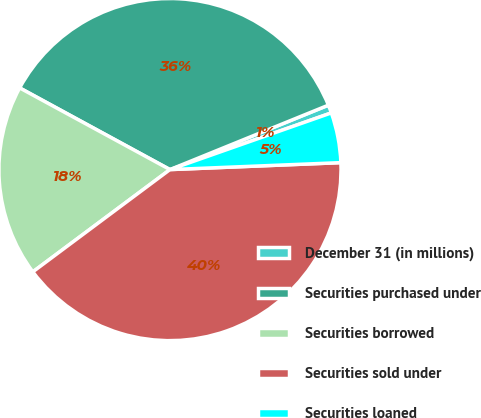Convert chart to OTSL. <chart><loc_0><loc_0><loc_500><loc_500><pie_chart><fcel>December 31 (in millions)<fcel>Securities purchased under<fcel>Securities borrowed<fcel>Securities sold under<fcel>Securities loaned<nl><fcel>0.77%<fcel>35.93%<fcel>18.12%<fcel>40.45%<fcel>4.73%<nl></chart> 